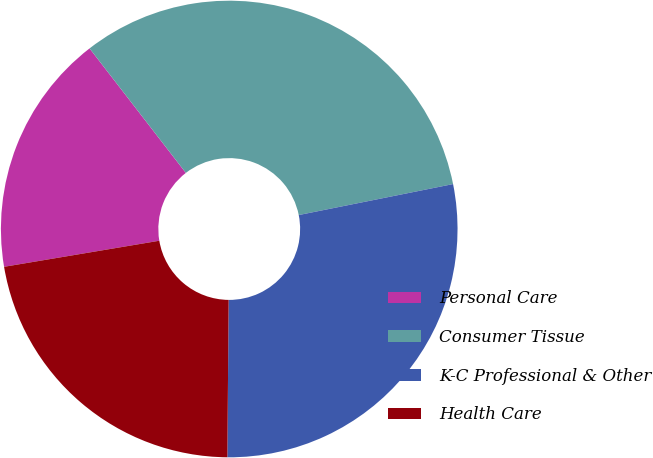Convert chart to OTSL. <chart><loc_0><loc_0><loc_500><loc_500><pie_chart><fcel>Personal Care<fcel>Consumer Tissue<fcel>K-C Professional & Other<fcel>Health Care<nl><fcel>17.17%<fcel>32.32%<fcel>28.28%<fcel>22.22%<nl></chart> 